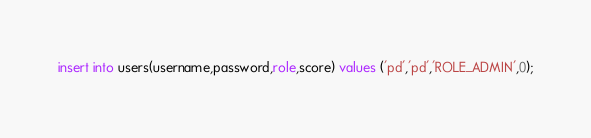<code> <loc_0><loc_0><loc_500><loc_500><_SQL_>insert into users(username,password,role,score) values ('pd','pd','ROLE_ADMIN',0);</code> 